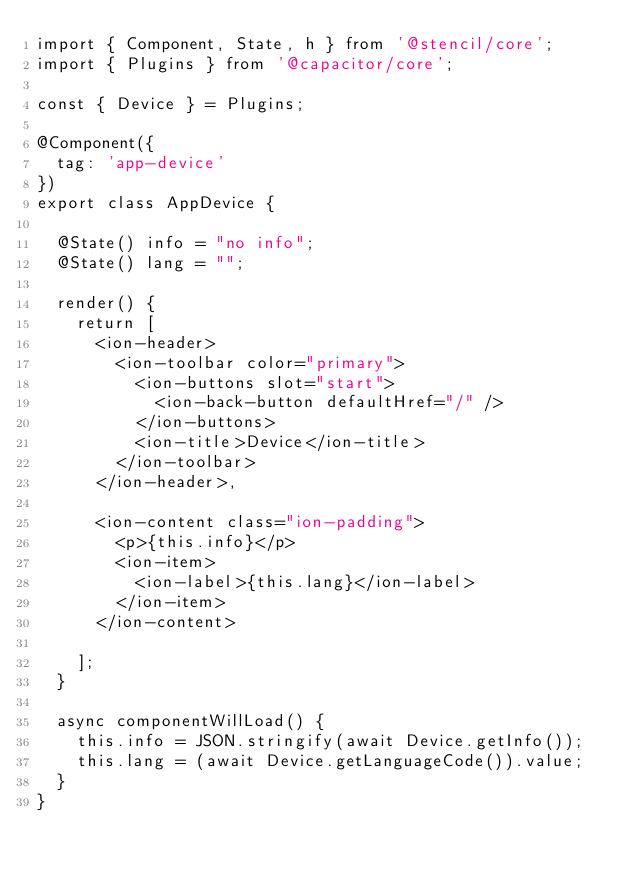<code> <loc_0><loc_0><loc_500><loc_500><_TypeScript_>import { Component, State, h } from '@stencil/core';
import { Plugins } from '@capacitor/core';

const { Device } = Plugins;

@Component({
  tag: 'app-device'
})
export class AppDevice {

  @State() info = "no info";
  @State() lang = "";

  render() {
    return [
      <ion-header>
        <ion-toolbar color="primary">
          <ion-buttons slot="start">
            <ion-back-button defaultHref="/" />
          </ion-buttons>
          <ion-title>Device</ion-title>
        </ion-toolbar>
      </ion-header>,

      <ion-content class="ion-padding">
        <p>{this.info}</p>
        <ion-item>
          <ion-label>{this.lang}</ion-label>
        </ion-item>
      </ion-content>
      
    ];
  }

  async componentWillLoad() {
    this.info = JSON.stringify(await Device.getInfo());
    this.lang = (await Device.getLanguageCode()).value;
  }
}
</code> 